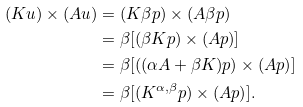<formula> <loc_0><loc_0><loc_500><loc_500>( K u ) \times ( A u ) & = ( K \beta p ) \times ( A \beta p ) \\ & = \beta [ ( \beta K p ) \times ( A p ) ] \\ & = \beta [ ( ( \alpha A + \beta K ) p ) \times ( A p ) ] \\ & = \beta [ ( K ^ { \alpha , \beta } p ) \times ( A p ) ] .</formula> 